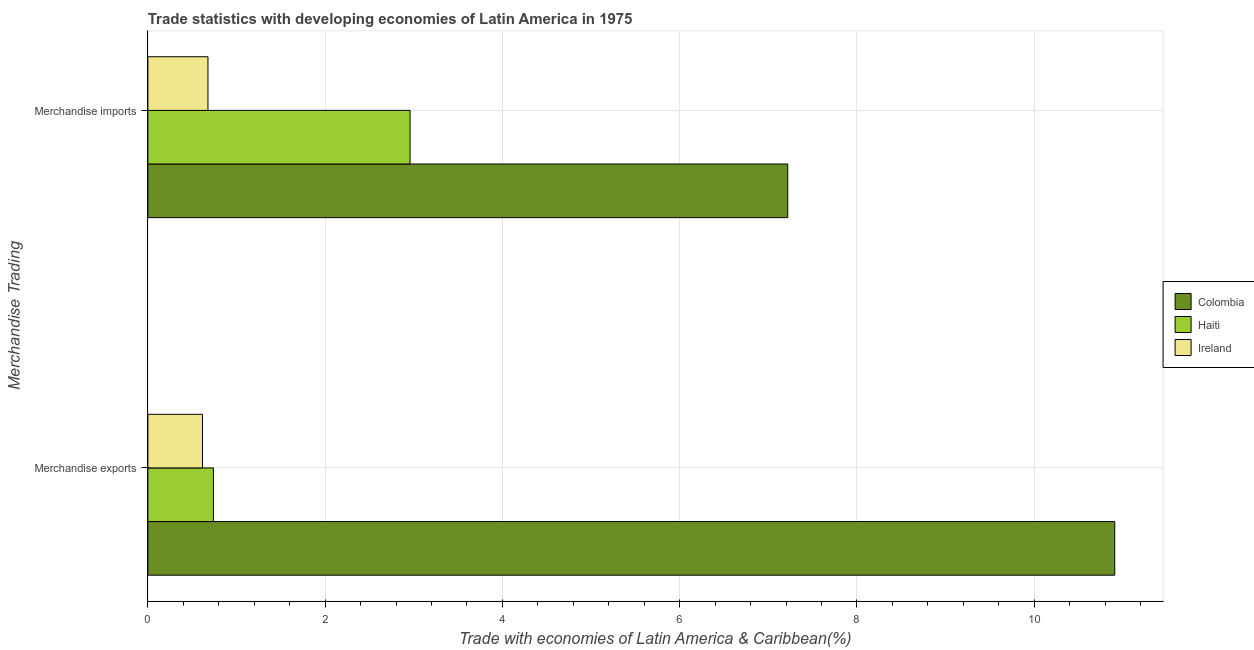How many different coloured bars are there?
Offer a very short reply. 3. Are the number of bars per tick equal to the number of legend labels?
Provide a succinct answer. Yes. How many bars are there on the 1st tick from the top?
Keep it short and to the point. 3. How many bars are there on the 2nd tick from the bottom?
Offer a terse response. 3. What is the merchandise exports in Haiti?
Your answer should be compact. 0.74. Across all countries, what is the maximum merchandise exports?
Your answer should be very brief. 10.91. Across all countries, what is the minimum merchandise exports?
Your answer should be very brief. 0.62. In which country was the merchandise exports maximum?
Provide a succinct answer. Colombia. In which country was the merchandise imports minimum?
Your response must be concise. Ireland. What is the total merchandise imports in the graph?
Ensure brevity in your answer.  10.86. What is the difference between the merchandise exports in Haiti and that in Colombia?
Offer a terse response. -10.17. What is the difference between the merchandise exports in Ireland and the merchandise imports in Colombia?
Provide a succinct answer. -6.6. What is the average merchandise imports per country?
Your response must be concise. 3.62. What is the difference between the merchandise exports and merchandise imports in Haiti?
Your answer should be compact. -2.22. What is the ratio of the merchandise exports in Haiti to that in Ireland?
Provide a succinct answer. 1.2. Is the merchandise imports in Ireland less than that in Colombia?
Offer a terse response. Yes. What does the 2nd bar from the top in Merchandise imports represents?
Offer a terse response. Haiti. What does the 1st bar from the bottom in Merchandise exports represents?
Give a very brief answer. Colombia. How many bars are there?
Keep it short and to the point. 6. Are all the bars in the graph horizontal?
Ensure brevity in your answer.  Yes. How many countries are there in the graph?
Your response must be concise. 3. Are the values on the major ticks of X-axis written in scientific E-notation?
Offer a very short reply. No. Does the graph contain any zero values?
Your response must be concise. No. Does the graph contain grids?
Provide a succinct answer. Yes. Where does the legend appear in the graph?
Give a very brief answer. Center right. What is the title of the graph?
Provide a short and direct response. Trade statistics with developing economies of Latin America in 1975. Does "Belarus" appear as one of the legend labels in the graph?
Provide a succinct answer. No. What is the label or title of the X-axis?
Provide a succinct answer. Trade with economies of Latin America & Caribbean(%). What is the label or title of the Y-axis?
Make the answer very short. Merchandise Trading. What is the Trade with economies of Latin America & Caribbean(%) in Colombia in Merchandise exports?
Make the answer very short. 10.91. What is the Trade with economies of Latin America & Caribbean(%) of Haiti in Merchandise exports?
Offer a very short reply. 0.74. What is the Trade with economies of Latin America & Caribbean(%) of Ireland in Merchandise exports?
Your answer should be compact. 0.62. What is the Trade with economies of Latin America & Caribbean(%) of Colombia in Merchandise imports?
Ensure brevity in your answer.  7.22. What is the Trade with economies of Latin America & Caribbean(%) of Haiti in Merchandise imports?
Your answer should be very brief. 2.96. What is the Trade with economies of Latin America & Caribbean(%) of Ireland in Merchandise imports?
Keep it short and to the point. 0.68. Across all Merchandise Trading, what is the maximum Trade with economies of Latin America & Caribbean(%) of Colombia?
Offer a terse response. 10.91. Across all Merchandise Trading, what is the maximum Trade with economies of Latin America & Caribbean(%) of Haiti?
Offer a terse response. 2.96. Across all Merchandise Trading, what is the maximum Trade with economies of Latin America & Caribbean(%) in Ireland?
Your response must be concise. 0.68. Across all Merchandise Trading, what is the minimum Trade with economies of Latin America & Caribbean(%) in Colombia?
Your answer should be compact. 7.22. Across all Merchandise Trading, what is the minimum Trade with economies of Latin America & Caribbean(%) of Haiti?
Give a very brief answer. 0.74. Across all Merchandise Trading, what is the minimum Trade with economies of Latin America & Caribbean(%) of Ireland?
Keep it short and to the point. 0.62. What is the total Trade with economies of Latin America & Caribbean(%) of Colombia in the graph?
Make the answer very short. 18.13. What is the total Trade with economies of Latin America & Caribbean(%) of Haiti in the graph?
Your answer should be compact. 3.7. What is the total Trade with economies of Latin America & Caribbean(%) of Ireland in the graph?
Offer a very short reply. 1.29. What is the difference between the Trade with economies of Latin America & Caribbean(%) of Colombia in Merchandise exports and that in Merchandise imports?
Make the answer very short. 3.69. What is the difference between the Trade with economies of Latin America & Caribbean(%) in Haiti in Merchandise exports and that in Merchandise imports?
Keep it short and to the point. -2.22. What is the difference between the Trade with economies of Latin America & Caribbean(%) of Ireland in Merchandise exports and that in Merchandise imports?
Provide a short and direct response. -0.06. What is the difference between the Trade with economies of Latin America & Caribbean(%) of Colombia in Merchandise exports and the Trade with economies of Latin America & Caribbean(%) of Haiti in Merchandise imports?
Keep it short and to the point. 7.95. What is the difference between the Trade with economies of Latin America & Caribbean(%) of Colombia in Merchandise exports and the Trade with economies of Latin America & Caribbean(%) of Ireland in Merchandise imports?
Provide a succinct answer. 10.23. What is the difference between the Trade with economies of Latin America & Caribbean(%) in Haiti in Merchandise exports and the Trade with economies of Latin America & Caribbean(%) in Ireland in Merchandise imports?
Your answer should be compact. 0.06. What is the average Trade with economies of Latin America & Caribbean(%) in Colombia per Merchandise Trading?
Ensure brevity in your answer.  9.06. What is the average Trade with economies of Latin America & Caribbean(%) of Haiti per Merchandise Trading?
Keep it short and to the point. 1.85. What is the average Trade with economies of Latin America & Caribbean(%) of Ireland per Merchandise Trading?
Provide a short and direct response. 0.65. What is the difference between the Trade with economies of Latin America & Caribbean(%) in Colombia and Trade with economies of Latin America & Caribbean(%) in Haiti in Merchandise exports?
Provide a short and direct response. 10.17. What is the difference between the Trade with economies of Latin America & Caribbean(%) in Colombia and Trade with economies of Latin America & Caribbean(%) in Ireland in Merchandise exports?
Keep it short and to the point. 10.29. What is the difference between the Trade with economies of Latin America & Caribbean(%) in Haiti and Trade with economies of Latin America & Caribbean(%) in Ireland in Merchandise exports?
Your response must be concise. 0.12. What is the difference between the Trade with economies of Latin America & Caribbean(%) in Colombia and Trade with economies of Latin America & Caribbean(%) in Haiti in Merchandise imports?
Keep it short and to the point. 4.26. What is the difference between the Trade with economies of Latin America & Caribbean(%) of Colombia and Trade with economies of Latin America & Caribbean(%) of Ireland in Merchandise imports?
Your response must be concise. 6.54. What is the difference between the Trade with economies of Latin America & Caribbean(%) in Haiti and Trade with economies of Latin America & Caribbean(%) in Ireland in Merchandise imports?
Ensure brevity in your answer.  2.28. What is the ratio of the Trade with economies of Latin America & Caribbean(%) of Colombia in Merchandise exports to that in Merchandise imports?
Give a very brief answer. 1.51. What is the ratio of the Trade with economies of Latin America & Caribbean(%) in Haiti in Merchandise exports to that in Merchandise imports?
Your answer should be compact. 0.25. What is the ratio of the Trade with economies of Latin America & Caribbean(%) of Ireland in Merchandise exports to that in Merchandise imports?
Keep it short and to the point. 0.91. What is the difference between the highest and the second highest Trade with economies of Latin America & Caribbean(%) in Colombia?
Keep it short and to the point. 3.69. What is the difference between the highest and the second highest Trade with economies of Latin America & Caribbean(%) of Haiti?
Your response must be concise. 2.22. What is the difference between the highest and the second highest Trade with economies of Latin America & Caribbean(%) in Ireland?
Your answer should be compact. 0.06. What is the difference between the highest and the lowest Trade with economies of Latin America & Caribbean(%) in Colombia?
Your answer should be very brief. 3.69. What is the difference between the highest and the lowest Trade with economies of Latin America & Caribbean(%) in Haiti?
Offer a terse response. 2.22. What is the difference between the highest and the lowest Trade with economies of Latin America & Caribbean(%) of Ireland?
Provide a succinct answer. 0.06. 